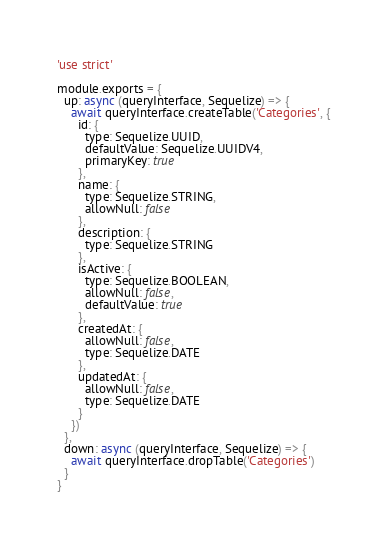<code> <loc_0><loc_0><loc_500><loc_500><_JavaScript_>'use strict'

module.exports = {
  up: async (queryInterface, Sequelize) => {
    await queryInterface.createTable('Categories', {
      id: {
        type: Sequelize.UUID,
        defaultValue: Sequelize.UUIDV4,
        primaryKey: true
      },
      name: {
        type: Sequelize.STRING,
        allowNull: false
      },
      description: {
        type: Sequelize.STRING
      },
      isActive: {
        type: Sequelize.BOOLEAN,
        allowNull: false,
        defaultValue: true
      },
      createdAt: {
        allowNull: false,
        type: Sequelize.DATE
      },
      updatedAt: {
        allowNull: false,
        type: Sequelize.DATE
      }
    })
  },
  down: async (queryInterface, Sequelize) => {
    await queryInterface.dropTable('Categories')
  }
}
</code> 